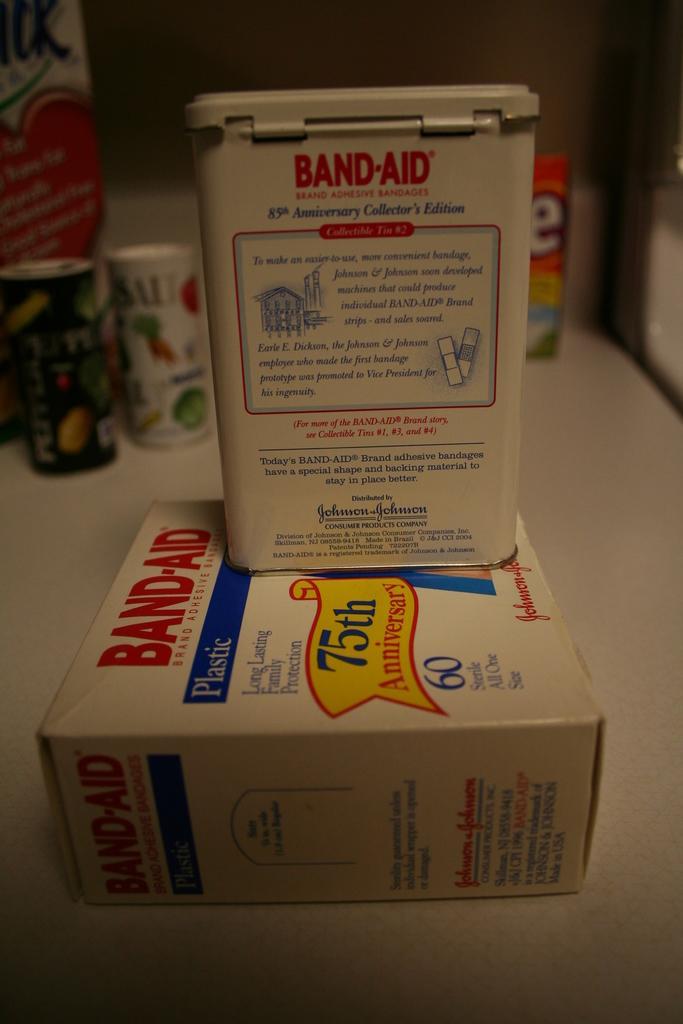Describe this image in one or two sentences. In this image there is a table and we can see a carton and tins placed on the table. 